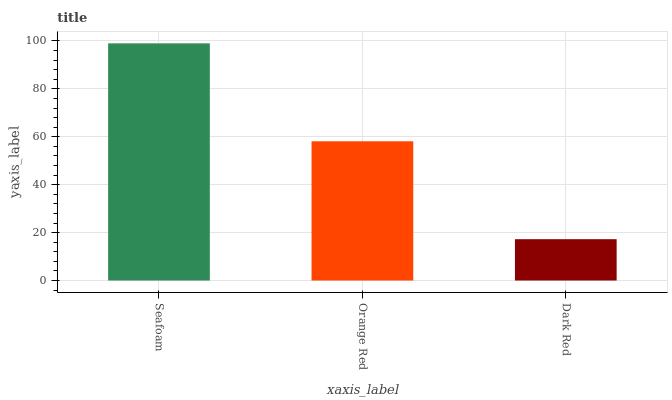Is Dark Red the minimum?
Answer yes or no. Yes. Is Seafoam the maximum?
Answer yes or no. Yes. Is Orange Red the minimum?
Answer yes or no. No. Is Orange Red the maximum?
Answer yes or no. No. Is Seafoam greater than Orange Red?
Answer yes or no. Yes. Is Orange Red less than Seafoam?
Answer yes or no. Yes. Is Orange Red greater than Seafoam?
Answer yes or no. No. Is Seafoam less than Orange Red?
Answer yes or no. No. Is Orange Red the high median?
Answer yes or no. Yes. Is Orange Red the low median?
Answer yes or no. Yes. Is Dark Red the high median?
Answer yes or no. No. Is Dark Red the low median?
Answer yes or no. No. 